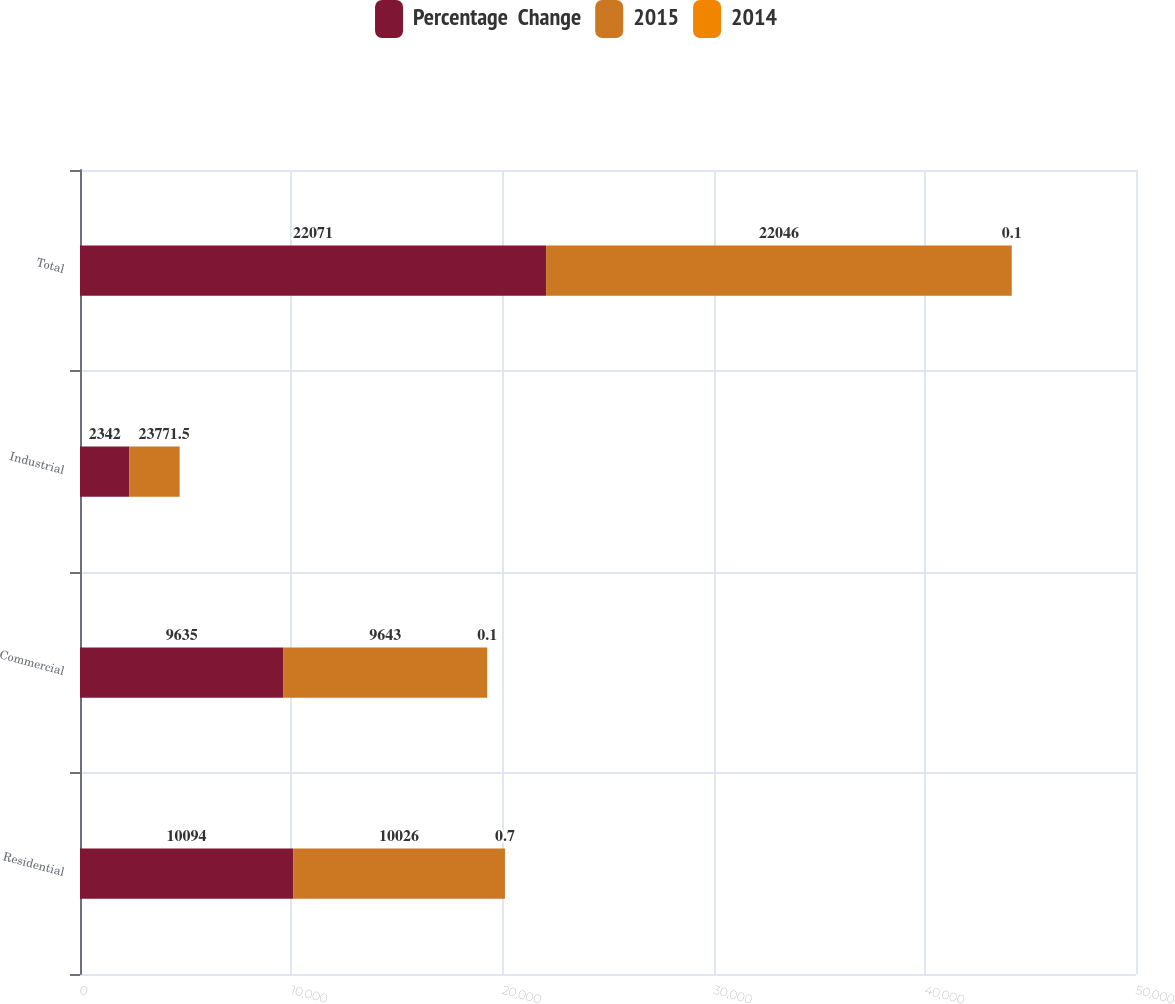<chart> <loc_0><loc_0><loc_500><loc_500><stacked_bar_chart><ecel><fcel>Residential<fcel>Commercial<fcel>Industrial<fcel>Total<nl><fcel>Percentage  Change<fcel>10094<fcel>9635<fcel>2342<fcel>22071<nl><fcel>2015<fcel>10026<fcel>9643<fcel>2377<fcel>22046<nl><fcel>2014<fcel>0.7<fcel>0.1<fcel>1.5<fcel>0.1<nl></chart> 